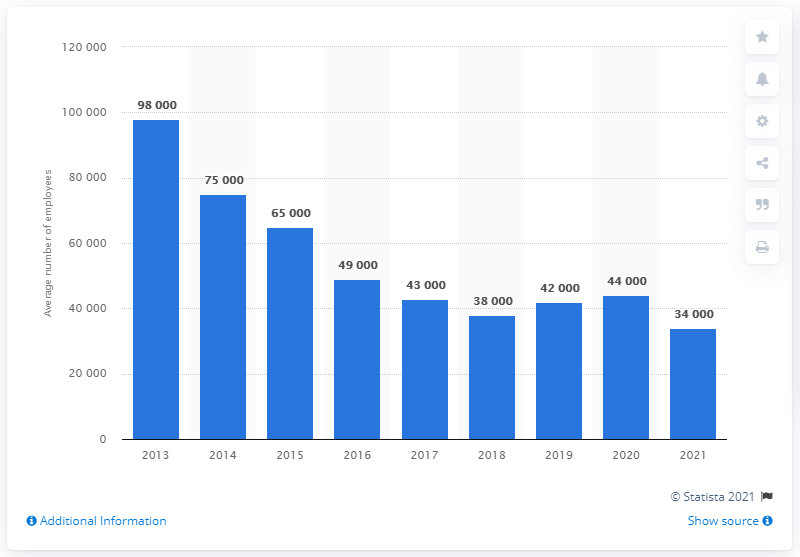Outline some significant characteristics in this image. According to data available in 2021, the average number of employees at the Abercrombie & Fitch Co. worldwide was approximately 34,000. The number of employees of the Abercrombie & Fitch Co. worldwide from 2018 to 2021 was approximately 158,000. 